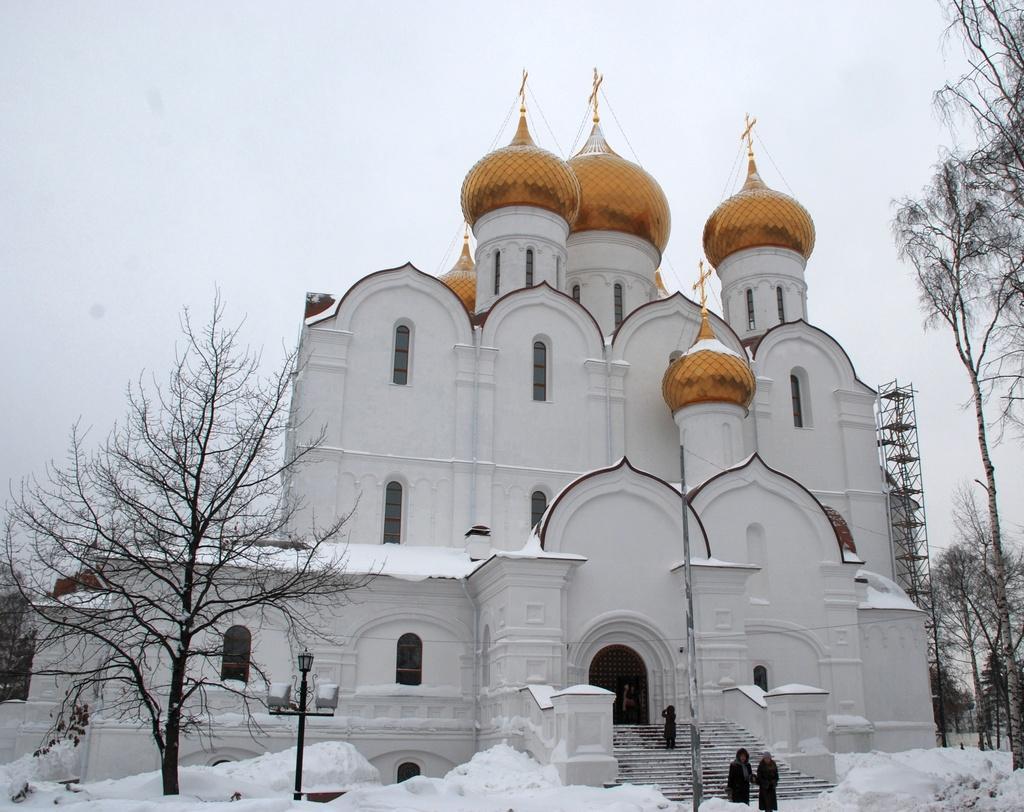Could you give a brief overview of what you see in this image? In this image we can see a building. The color of the building is white. Right side of the image we can see trees. In front of the building people are moving. The sky is totally white and left side of the image one more tree is present. 